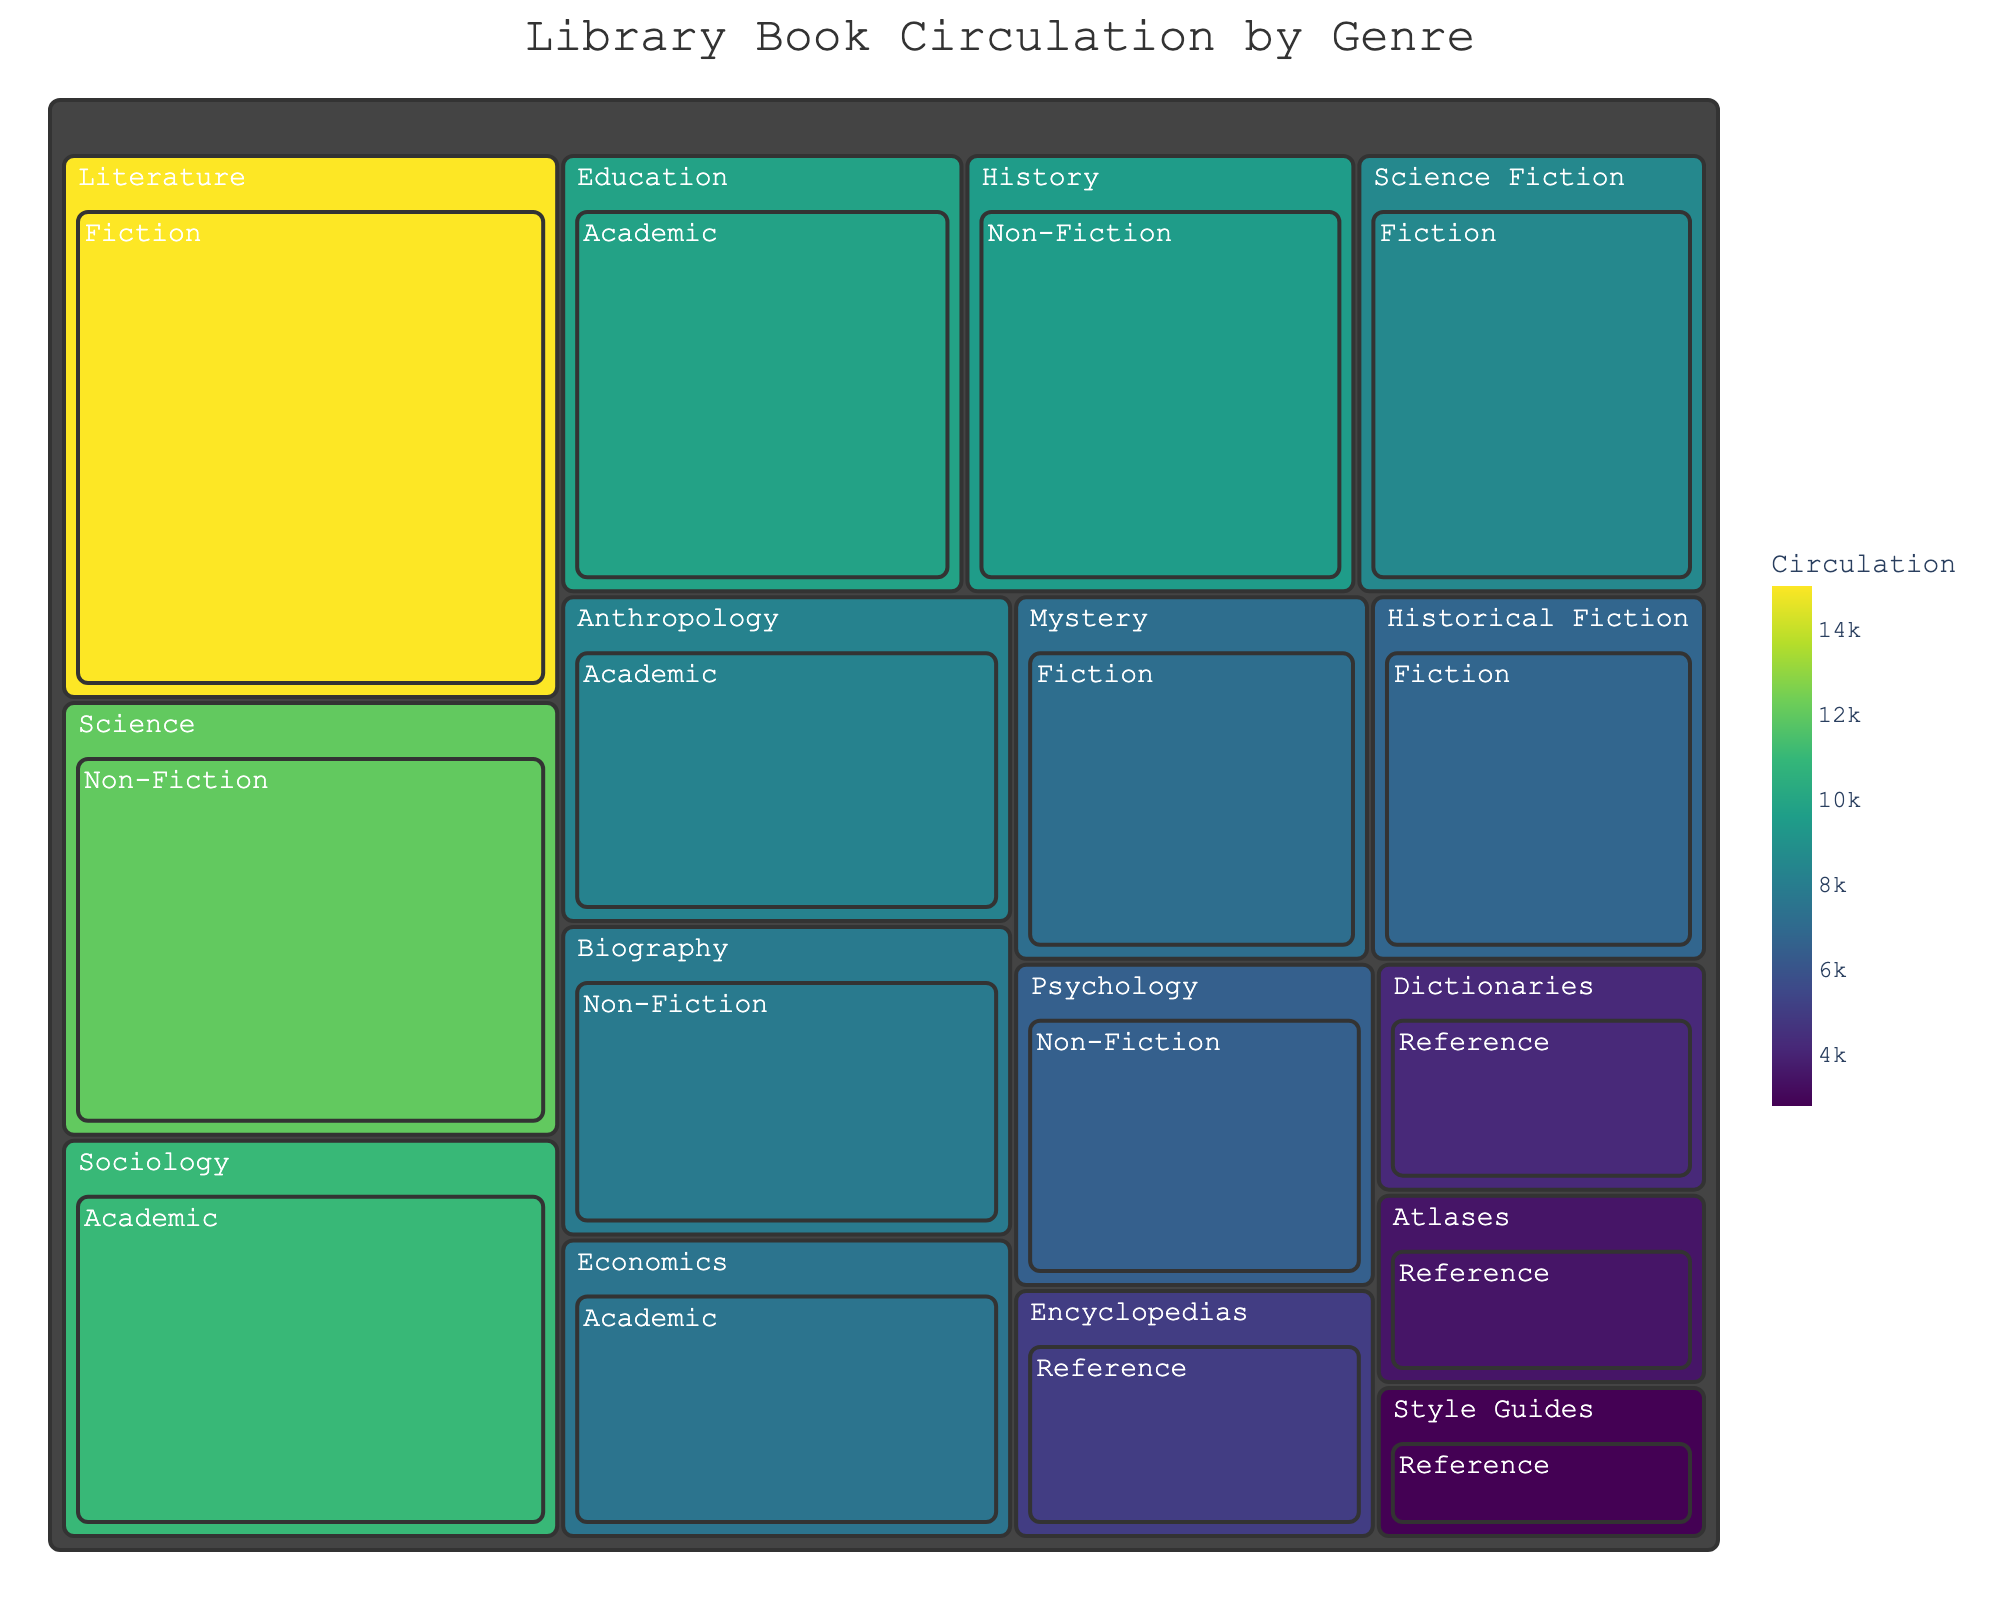How many genres are represented in the Fiction category? To determine the number of genres in the Fiction category, look at the breakdown of different segments under Fiction. There are Literature, Science Fiction, Mystery, and Historical Fiction.
Answer: 4 Which category has the highest circulation? Identify the segment with the largest area and highest value. Non-Fiction with Science @ 12,000 circulation is the highest.
Answer: Science (Non-Fiction), 12,000 What is the total circulation for the Reference category? Add the circulation numbers for all sub-categories under Reference: Encyclopedias (5,000) + Dictionaries (4,200) + Atlases (3,500) + Style Guides (2,800) = 15,500
Answer: 15,500 Compare the circulation between the Fiction and Academic categories. Which has more circulation and by how much? Calculate the total circulation for both categories. Fiction: 15,000 + 8,500 + 7,200 + 6,800 = 37,500. Academic: 11,000 + 9,800 + 8,200 + 7,500 = 36,500. Fiction has 1,000 more circulation.
Answer: Fiction, by 1,000 Which sub-category within Academic has the third highest circulation? Within Academic, arrange the circulation numbers in descending order: Sociology (11,000), Education (9,800), Anthropology (8,200), Economics (7,500). The third highest is Anthropology.
Answer: Anthropology What is the average circulation of all genres within the Non-Fiction category? Sum all the circulation numbers in the Non-Fiction category and then divide by the number of genres: (12,000 + 9,500 + 7,800 + 6,500) / 4 = 35,800 / 4 = 8,950
Answer: 8,950 Is the circulation of Historical Fiction greater than the combined circulation of all Reference sub-categories? Historical Fiction has 6,800 circulation. Sum the Reference category circulation numbers: Encyclopedias (5,000) + Dictionaries (4,200) + Atlases (3,500) + Style Guides (2,800) = 15,500. Historical Fiction is less.
Answer: No Which category has more genres included: Fiction or Reference? Simply count the number of genres in each category. Fiction has Literature, Science Fiction, Mystery, Historical Fiction = 4. Reference has Encyclopedias, Dictionaries, Atlases, Style Guides = 4. They are equal.
Answer: Both have 4 each What is the combined circulation of Literature and Science Fiction genres? Add the circulation values for Literature (15,000) and Science Fiction (8,500): 15,000 + 8,500 = 23,500
Answer: 23,500 What percentage of the total circulation does the Non-Fiction category represent? First, find the total circulation across all categories, then calculate Non-Fiction's share. Total circulation = 15,000 + 8,500 + 7,200 + 6,800 + 12,000 + 9,500 + 7,800 + 6,500 + 11,000 + 9,800 + 8,200 + 7,500 + 5,000 + 4,200 + 3,500 + 2,800 = 136,300. Non-Fiction's circulation = 12,000 + 9,500 + 7,800 + 6,500 = 35,800. Percentage = (35,800 / 136,300) * 100% ≈ 26.26%
Answer: 26.26% 